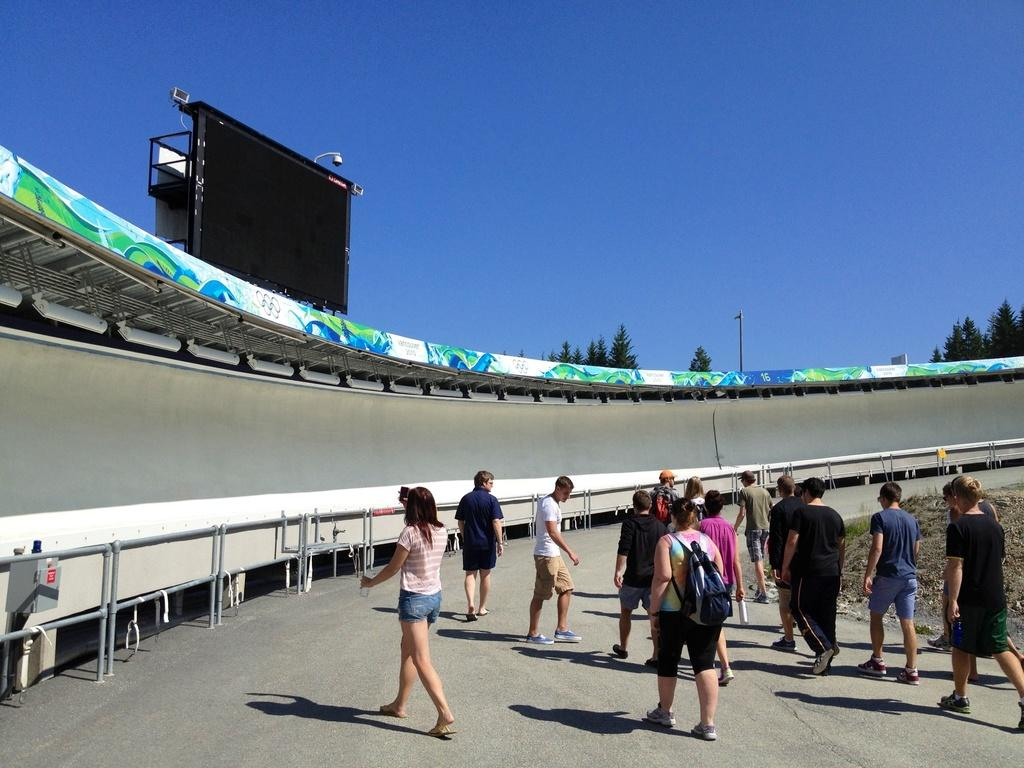What are the people in the image doing? There is a group of people walking in the image. What type of surface are they walking on? The ground appears to be grass. What structure can be seen in the image? There is a scoreboard in the image. What type of vegetation is present in the image? There are trees in the image. What architectural feature is visible in the image? There is a wall in the image. What type of apparel is the order wearing in the image? There is no mention of an order or any specific apparel in the image; it features a group of people walking on grass. 